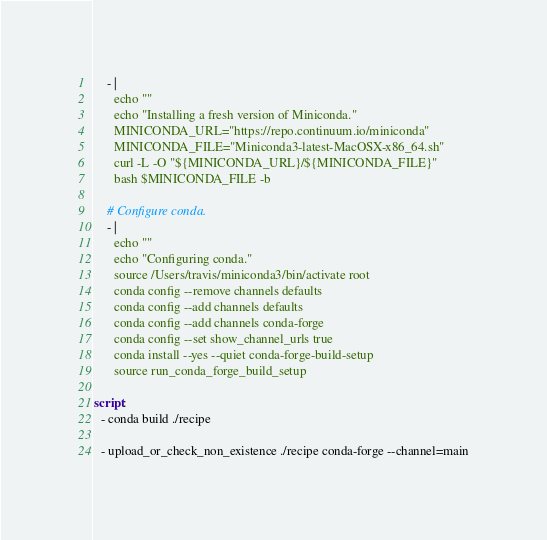<code> <loc_0><loc_0><loc_500><loc_500><_YAML_>    - |
      echo ""
      echo "Installing a fresh version of Miniconda."
      MINICONDA_URL="https://repo.continuum.io/miniconda"
      MINICONDA_FILE="Miniconda3-latest-MacOSX-x86_64.sh"
      curl -L -O "${MINICONDA_URL}/${MINICONDA_FILE}"
      bash $MINICONDA_FILE -b

    # Configure conda.
    - |
      echo ""
      echo "Configuring conda."
      source /Users/travis/miniconda3/bin/activate root
      conda config --remove channels defaults
      conda config --add channels defaults
      conda config --add channels conda-forge
      conda config --set show_channel_urls true
      conda install --yes --quiet conda-forge-build-setup
      source run_conda_forge_build_setup

script:
  - conda build ./recipe

  - upload_or_check_non_existence ./recipe conda-forge --channel=main
</code> 